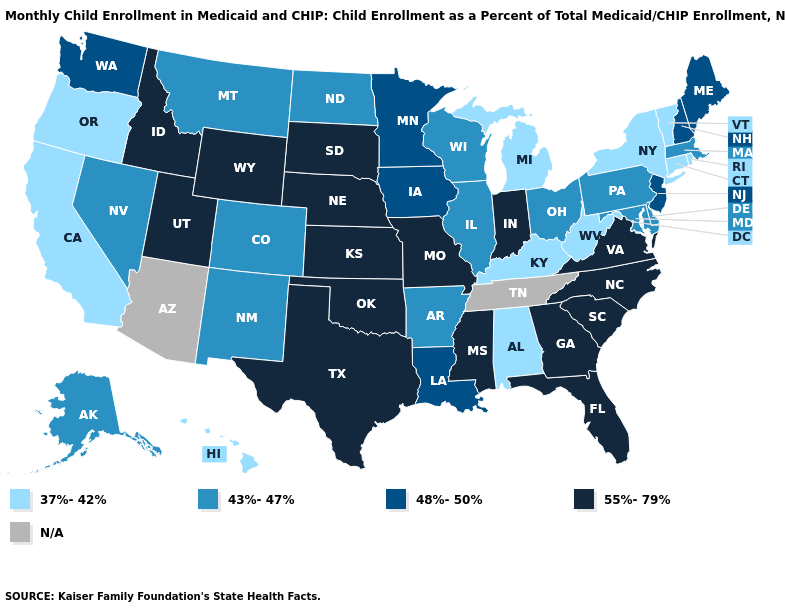Name the states that have a value in the range 55%-79%?
Give a very brief answer. Florida, Georgia, Idaho, Indiana, Kansas, Mississippi, Missouri, Nebraska, North Carolina, Oklahoma, South Carolina, South Dakota, Texas, Utah, Virginia, Wyoming. Which states have the lowest value in the South?
Be succinct. Alabama, Kentucky, West Virginia. What is the value of Indiana?
Quick response, please. 55%-79%. What is the value of Mississippi?
Give a very brief answer. 55%-79%. What is the value of North Dakota?
Write a very short answer. 43%-47%. What is the value of Iowa?
Short answer required. 48%-50%. Which states have the lowest value in the South?
Quick response, please. Alabama, Kentucky, West Virginia. Name the states that have a value in the range N/A?
Be succinct. Arizona, Tennessee. Among the states that border Utah , does New Mexico have the lowest value?
Write a very short answer. Yes. Name the states that have a value in the range N/A?
Keep it brief. Arizona, Tennessee. What is the value of New Mexico?
Write a very short answer. 43%-47%. Among the states that border Oregon , does California have the lowest value?
Answer briefly. Yes. How many symbols are there in the legend?
Write a very short answer. 5. Which states have the highest value in the USA?
Short answer required. Florida, Georgia, Idaho, Indiana, Kansas, Mississippi, Missouri, Nebraska, North Carolina, Oklahoma, South Carolina, South Dakota, Texas, Utah, Virginia, Wyoming. 